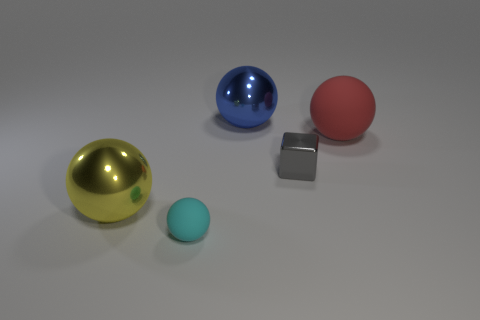Subtract all tiny cyan spheres. How many spheres are left? 3 Add 5 tiny cyan rubber spheres. How many objects exist? 10 Subtract all yellow spheres. How many spheres are left? 3 Subtract all spheres. How many objects are left? 1 Subtract 3 balls. How many balls are left? 1 Subtract all yellow blocks. How many brown spheres are left? 0 Subtract all large brown shiny balls. Subtract all large blue shiny things. How many objects are left? 4 Add 4 big yellow shiny balls. How many big yellow shiny balls are left? 5 Add 2 big purple matte cylinders. How many big purple matte cylinders exist? 2 Subtract 0 green blocks. How many objects are left? 5 